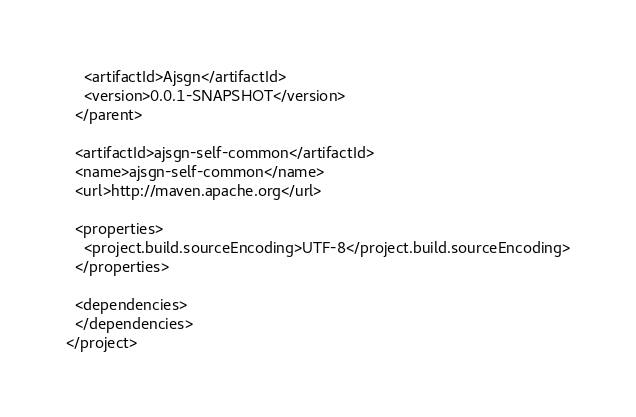Convert code to text. <code><loc_0><loc_0><loc_500><loc_500><_XML_>    <artifactId>Ajsgn</artifactId>
    <version>0.0.1-SNAPSHOT</version>
  </parent>
  
  <artifactId>ajsgn-self-common</artifactId>
  <name>ajsgn-self-common</name>
  <url>http://maven.apache.org</url>
  
  <properties>
    <project.build.sourceEncoding>UTF-8</project.build.sourceEncoding>
  </properties>
  
  <dependencies>
  </dependencies>
</project>
</code> 